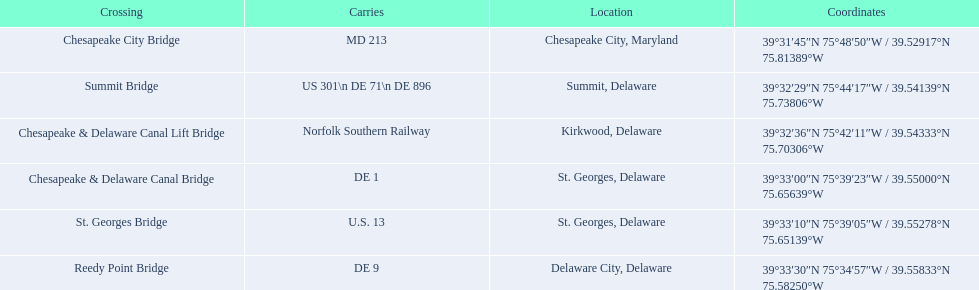Can you name the bridges found in delaware? Summit Bridge, Chesapeake & Delaware Canal Lift Bridge, Chesapeake & Delaware Canal Bridge, St. Georges Bridge, Reedy Point Bridge. Which bridge is responsible for carrying de 9? Reedy Point Bridge. 